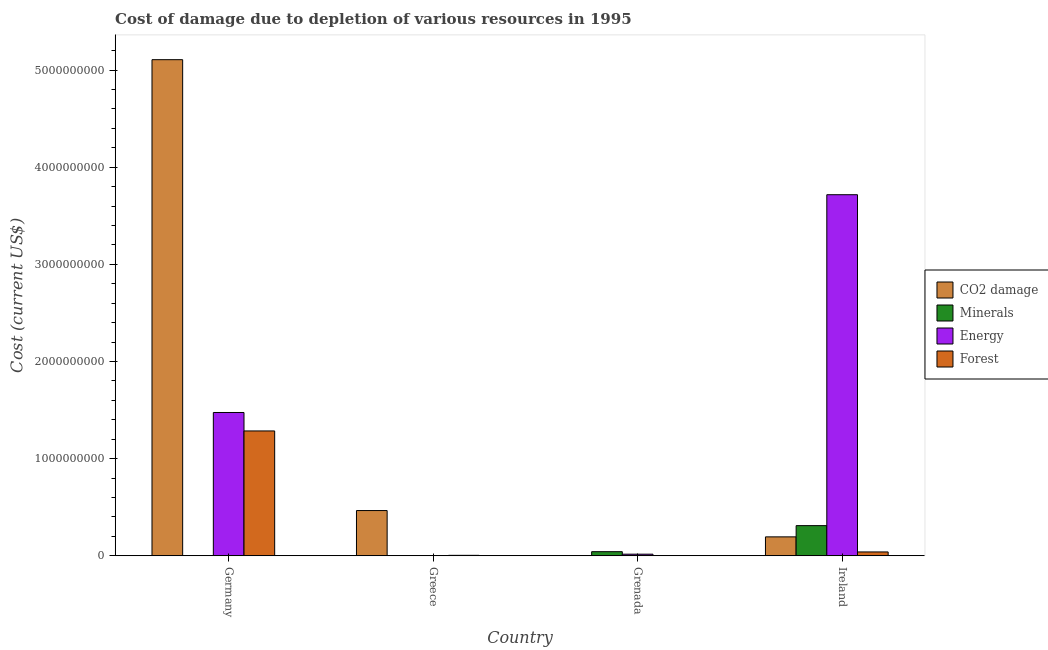Are the number of bars on each tick of the X-axis equal?
Make the answer very short. Yes. How many bars are there on the 3rd tick from the right?
Give a very brief answer. 4. What is the label of the 4th group of bars from the left?
Your response must be concise. Ireland. In how many cases, is the number of bars for a given country not equal to the number of legend labels?
Offer a very short reply. 0. What is the cost of damage due to depletion of minerals in Grenada?
Make the answer very short. 4.23e+07. Across all countries, what is the maximum cost of damage due to depletion of minerals?
Give a very brief answer. 3.10e+08. Across all countries, what is the minimum cost of damage due to depletion of coal?
Make the answer very short. 9.10e+05. In which country was the cost of damage due to depletion of minerals maximum?
Your answer should be very brief. Ireland. What is the total cost of damage due to depletion of energy in the graph?
Offer a terse response. 5.21e+09. What is the difference between the cost of damage due to depletion of minerals in Germany and that in Grenada?
Keep it short and to the point. -4.22e+07. What is the difference between the cost of damage due to depletion of coal in Grenada and the cost of damage due to depletion of forests in Ireland?
Provide a succinct answer. -3.88e+07. What is the average cost of damage due to depletion of coal per country?
Your answer should be very brief. 1.44e+09. What is the difference between the cost of damage due to depletion of forests and cost of damage due to depletion of minerals in Ireland?
Keep it short and to the point. -2.71e+08. What is the ratio of the cost of damage due to depletion of forests in Greece to that in Grenada?
Offer a terse response. 4.46. What is the difference between the highest and the second highest cost of damage due to depletion of energy?
Your answer should be compact. 2.24e+09. What is the difference between the highest and the lowest cost of damage due to depletion of minerals?
Your answer should be compact. 3.10e+08. In how many countries, is the cost of damage due to depletion of energy greater than the average cost of damage due to depletion of energy taken over all countries?
Provide a succinct answer. 2. What does the 1st bar from the left in Germany represents?
Your response must be concise. CO2 damage. What does the 1st bar from the right in Ireland represents?
Your response must be concise. Forest. Is it the case that in every country, the sum of the cost of damage due to depletion of coal and cost of damage due to depletion of minerals is greater than the cost of damage due to depletion of energy?
Your response must be concise. No. How many countries are there in the graph?
Offer a very short reply. 4. What is the difference between two consecutive major ticks on the Y-axis?
Your response must be concise. 1.00e+09. Are the values on the major ticks of Y-axis written in scientific E-notation?
Your response must be concise. No. Does the graph contain any zero values?
Provide a succinct answer. No. How many legend labels are there?
Your answer should be compact. 4. How are the legend labels stacked?
Give a very brief answer. Vertical. What is the title of the graph?
Offer a very short reply. Cost of damage due to depletion of various resources in 1995 . What is the label or title of the Y-axis?
Your answer should be very brief. Cost (current US$). What is the Cost (current US$) in CO2 damage in Germany?
Offer a terse response. 5.11e+09. What is the Cost (current US$) of Minerals in Germany?
Your response must be concise. 5.69e+04. What is the Cost (current US$) of Energy in Germany?
Give a very brief answer. 1.47e+09. What is the Cost (current US$) of Forest in Germany?
Provide a short and direct response. 1.29e+09. What is the Cost (current US$) of CO2 damage in Greece?
Your answer should be compact. 4.66e+08. What is the Cost (current US$) in Minerals in Greece?
Make the answer very short. 2.68e+06. What is the Cost (current US$) in Energy in Greece?
Provide a succinct answer. 2.56e+06. What is the Cost (current US$) in Forest in Greece?
Your answer should be very brief. 4.73e+06. What is the Cost (current US$) of CO2 damage in Grenada?
Your answer should be compact. 9.10e+05. What is the Cost (current US$) in Minerals in Grenada?
Offer a terse response. 4.23e+07. What is the Cost (current US$) of Energy in Grenada?
Provide a short and direct response. 1.66e+07. What is the Cost (current US$) of Forest in Grenada?
Offer a very short reply. 1.06e+06. What is the Cost (current US$) in CO2 damage in Ireland?
Your answer should be very brief. 1.95e+08. What is the Cost (current US$) in Minerals in Ireland?
Provide a succinct answer. 3.10e+08. What is the Cost (current US$) in Energy in Ireland?
Your response must be concise. 3.72e+09. What is the Cost (current US$) of Forest in Ireland?
Your answer should be compact. 3.97e+07. Across all countries, what is the maximum Cost (current US$) of CO2 damage?
Your response must be concise. 5.11e+09. Across all countries, what is the maximum Cost (current US$) in Minerals?
Make the answer very short. 3.10e+08. Across all countries, what is the maximum Cost (current US$) of Energy?
Provide a short and direct response. 3.72e+09. Across all countries, what is the maximum Cost (current US$) of Forest?
Your answer should be very brief. 1.29e+09. Across all countries, what is the minimum Cost (current US$) in CO2 damage?
Keep it short and to the point. 9.10e+05. Across all countries, what is the minimum Cost (current US$) of Minerals?
Offer a very short reply. 5.69e+04. Across all countries, what is the minimum Cost (current US$) in Energy?
Offer a very short reply. 2.56e+06. Across all countries, what is the minimum Cost (current US$) in Forest?
Offer a terse response. 1.06e+06. What is the total Cost (current US$) of CO2 damage in the graph?
Provide a succinct answer. 5.77e+09. What is the total Cost (current US$) of Minerals in the graph?
Your answer should be compact. 3.56e+08. What is the total Cost (current US$) in Energy in the graph?
Offer a terse response. 5.21e+09. What is the total Cost (current US$) of Forest in the graph?
Your answer should be compact. 1.33e+09. What is the difference between the Cost (current US$) of CO2 damage in Germany and that in Greece?
Give a very brief answer. 4.64e+09. What is the difference between the Cost (current US$) of Minerals in Germany and that in Greece?
Provide a succinct answer. -2.63e+06. What is the difference between the Cost (current US$) of Energy in Germany and that in Greece?
Your answer should be compact. 1.47e+09. What is the difference between the Cost (current US$) of Forest in Germany and that in Greece?
Your answer should be very brief. 1.28e+09. What is the difference between the Cost (current US$) of CO2 damage in Germany and that in Grenada?
Offer a terse response. 5.11e+09. What is the difference between the Cost (current US$) in Minerals in Germany and that in Grenada?
Provide a succinct answer. -4.22e+07. What is the difference between the Cost (current US$) of Energy in Germany and that in Grenada?
Make the answer very short. 1.46e+09. What is the difference between the Cost (current US$) in Forest in Germany and that in Grenada?
Offer a terse response. 1.28e+09. What is the difference between the Cost (current US$) of CO2 damage in Germany and that in Ireland?
Make the answer very short. 4.91e+09. What is the difference between the Cost (current US$) in Minerals in Germany and that in Ireland?
Offer a terse response. -3.10e+08. What is the difference between the Cost (current US$) of Energy in Germany and that in Ireland?
Your answer should be very brief. -2.24e+09. What is the difference between the Cost (current US$) of Forest in Germany and that in Ireland?
Ensure brevity in your answer.  1.25e+09. What is the difference between the Cost (current US$) in CO2 damage in Greece and that in Grenada?
Offer a very short reply. 4.65e+08. What is the difference between the Cost (current US$) of Minerals in Greece and that in Grenada?
Ensure brevity in your answer.  -3.96e+07. What is the difference between the Cost (current US$) in Energy in Greece and that in Grenada?
Keep it short and to the point. -1.40e+07. What is the difference between the Cost (current US$) of Forest in Greece and that in Grenada?
Offer a very short reply. 3.67e+06. What is the difference between the Cost (current US$) in CO2 damage in Greece and that in Ireland?
Make the answer very short. 2.71e+08. What is the difference between the Cost (current US$) in Minerals in Greece and that in Ireland?
Ensure brevity in your answer.  -3.08e+08. What is the difference between the Cost (current US$) in Energy in Greece and that in Ireland?
Provide a succinct answer. -3.71e+09. What is the difference between the Cost (current US$) of Forest in Greece and that in Ireland?
Provide a short and direct response. -3.49e+07. What is the difference between the Cost (current US$) of CO2 damage in Grenada and that in Ireland?
Provide a short and direct response. -1.94e+08. What is the difference between the Cost (current US$) in Minerals in Grenada and that in Ireland?
Provide a succinct answer. -2.68e+08. What is the difference between the Cost (current US$) of Energy in Grenada and that in Ireland?
Your answer should be very brief. -3.70e+09. What is the difference between the Cost (current US$) of Forest in Grenada and that in Ireland?
Your response must be concise. -3.86e+07. What is the difference between the Cost (current US$) in CO2 damage in Germany and the Cost (current US$) in Minerals in Greece?
Offer a terse response. 5.10e+09. What is the difference between the Cost (current US$) in CO2 damage in Germany and the Cost (current US$) in Energy in Greece?
Provide a succinct answer. 5.10e+09. What is the difference between the Cost (current US$) of CO2 damage in Germany and the Cost (current US$) of Forest in Greece?
Make the answer very short. 5.10e+09. What is the difference between the Cost (current US$) of Minerals in Germany and the Cost (current US$) of Energy in Greece?
Keep it short and to the point. -2.51e+06. What is the difference between the Cost (current US$) in Minerals in Germany and the Cost (current US$) in Forest in Greece?
Ensure brevity in your answer.  -4.67e+06. What is the difference between the Cost (current US$) in Energy in Germany and the Cost (current US$) in Forest in Greece?
Offer a very short reply. 1.47e+09. What is the difference between the Cost (current US$) of CO2 damage in Germany and the Cost (current US$) of Minerals in Grenada?
Make the answer very short. 5.06e+09. What is the difference between the Cost (current US$) in CO2 damage in Germany and the Cost (current US$) in Energy in Grenada?
Offer a very short reply. 5.09e+09. What is the difference between the Cost (current US$) in CO2 damage in Germany and the Cost (current US$) in Forest in Grenada?
Offer a very short reply. 5.11e+09. What is the difference between the Cost (current US$) of Minerals in Germany and the Cost (current US$) of Energy in Grenada?
Keep it short and to the point. -1.65e+07. What is the difference between the Cost (current US$) of Minerals in Germany and the Cost (current US$) of Forest in Grenada?
Make the answer very short. -1.00e+06. What is the difference between the Cost (current US$) in Energy in Germany and the Cost (current US$) in Forest in Grenada?
Provide a short and direct response. 1.47e+09. What is the difference between the Cost (current US$) in CO2 damage in Germany and the Cost (current US$) in Minerals in Ireland?
Give a very brief answer. 4.80e+09. What is the difference between the Cost (current US$) of CO2 damage in Germany and the Cost (current US$) of Energy in Ireland?
Provide a succinct answer. 1.39e+09. What is the difference between the Cost (current US$) of CO2 damage in Germany and the Cost (current US$) of Forest in Ireland?
Ensure brevity in your answer.  5.07e+09. What is the difference between the Cost (current US$) of Minerals in Germany and the Cost (current US$) of Energy in Ireland?
Offer a terse response. -3.72e+09. What is the difference between the Cost (current US$) of Minerals in Germany and the Cost (current US$) of Forest in Ireland?
Keep it short and to the point. -3.96e+07. What is the difference between the Cost (current US$) of Energy in Germany and the Cost (current US$) of Forest in Ireland?
Offer a very short reply. 1.44e+09. What is the difference between the Cost (current US$) in CO2 damage in Greece and the Cost (current US$) in Minerals in Grenada?
Give a very brief answer. 4.23e+08. What is the difference between the Cost (current US$) in CO2 damage in Greece and the Cost (current US$) in Energy in Grenada?
Your response must be concise. 4.49e+08. What is the difference between the Cost (current US$) in CO2 damage in Greece and the Cost (current US$) in Forest in Grenada?
Your answer should be very brief. 4.64e+08. What is the difference between the Cost (current US$) of Minerals in Greece and the Cost (current US$) of Energy in Grenada?
Give a very brief answer. -1.39e+07. What is the difference between the Cost (current US$) of Minerals in Greece and the Cost (current US$) of Forest in Grenada?
Ensure brevity in your answer.  1.62e+06. What is the difference between the Cost (current US$) in Energy in Greece and the Cost (current US$) in Forest in Grenada?
Provide a succinct answer. 1.51e+06. What is the difference between the Cost (current US$) in CO2 damage in Greece and the Cost (current US$) in Minerals in Ireland?
Your response must be concise. 1.55e+08. What is the difference between the Cost (current US$) in CO2 damage in Greece and the Cost (current US$) in Energy in Ireland?
Keep it short and to the point. -3.25e+09. What is the difference between the Cost (current US$) in CO2 damage in Greece and the Cost (current US$) in Forest in Ireland?
Ensure brevity in your answer.  4.26e+08. What is the difference between the Cost (current US$) of Minerals in Greece and the Cost (current US$) of Energy in Ireland?
Make the answer very short. -3.71e+09. What is the difference between the Cost (current US$) in Minerals in Greece and the Cost (current US$) in Forest in Ireland?
Keep it short and to the point. -3.70e+07. What is the difference between the Cost (current US$) of Energy in Greece and the Cost (current US$) of Forest in Ireland?
Provide a short and direct response. -3.71e+07. What is the difference between the Cost (current US$) of CO2 damage in Grenada and the Cost (current US$) of Minerals in Ireland?
Your response must be concise. -3.10e+08. What is the difference between the Cost (current US$) in CO2 damage in Grenada and the Cost (current US$) in Energy in Ireland?
Your answer should be very brief. -3.72e+09. What is the difference between the Cost (current US$) in CO2 damage in Grenada and the Cost (current US$) in Forest in Ireland?
Provide a short and direct response. -3.88e+07. What is the difference between the Cost (current US$) in Minerals in Grenada and the Cost (current US$) in Energy in Ireland?
Offer a terse response. -3.67e+09. What is the difference between the Cost (current US$) of Minerals in Grenada and the Cost (current US$) of Forest in Ireland?
Your answer should be very brief. 2.64e+06. What is the difference between the Cost (current US$) of Energy in Grenada and the Cost (current US$) of Forest in Ireland?
Provide a succinct answer. -2.31e+07. What is the average Cost (current US$) of CO2 damage per country?
Your response must be concise. 1.44e+09. What is the average Cost (current US$) of Minerals per country?
Provide a short and direct response. 8.89e+07. What is the average Cost (current US$) of Energy per country?
Give a very brief answer. 1.30e+09. What is the average Cost (current US$) of Forest per country?
Offer a very short reply. 3.33e+08. What is the difference between the Cost (current US$) of CO2 damage and Cost (current US$) of Minerals in Germany?
Provide a succinct answer. 5.11e+09. What is the difference between the Cost (current US$) of CO2 damage and Cost (current US$) of Energy in Germany?
Make the answer very short. 3.63e+09. What is the difference between the Cost (current US$) of CO2 damage and Cost (current US$) of Forest in Germany?
Ensure brevity in your answer.  3.82e+09. What is the difference between the Cost (current US$) in Minerals and Cost (current US$) in Energy in Germany?
Provide a succinct answer. -1.47e+09. What is the difference between the Cost (current US$) of Minerals and Cost (current US$) of Forest in Germany?
Your answer should be compact. -1.29e+09. What is the difference between the Cost (current US$) in Energy and Cost (current US$) in Forest in Germany?
Provide a succinct answer. 1.90e+08. What is the difference between the Cost (current US$) in CO2 damage and Cost (current US$) in Minerals in Greece?
Keep it short and to the point. 4.63e+08. What is the difference between the Cost (current US$) in CO2 damage and Cost (current US$) in Energy in Greece?
Give a very brief answer. 4.63e+08. What is the difference between the Cost (current US$) of CO2 damage and Cost (current US$) of Forest in Greece?
Offer a terse response. 4.61e+08. What is the difference between the Cost (current US$) of Minerals and Cost (current US$) of Energy in Greece?
Make the answer very short. 1.20e+05. What is the difference between the Cost (current US$) of Minerals and Cost (current US$) of Forest in Greece?
Ensure brevity in your answer.  -2.04e+06. What is the difference between the Cost (current US$) in Energy and Cost (current US$) in Forest in Greece?
Give a very brief answer. -2.16e+06. What is the difference between the Cost (current US$) in CO2 damage and Cost (current US$) in Minerals in Grenada?
Your answer should be compact. -4.14e+07. What is the difference between the Cost (current US$) in CO2 damage and Cost (current US$) in Energy in Grenada?
Your answer should be compact. -1.56e+07. What is the difference between the Cost (current US$) in CO2 damage and Cost (current US$) in Forest in Grenada?
Offer a very short reply. -1.50e+05. What is the difference between the Cost (current US$) of Minerals and Cost (current US$) of Energy in Grenada?
Ensure brevity in your answer.  2.58e+07. What is the difference between the Cost (current US$) of Minerals and Cost (current US$) of Forest in Grenada?
Provide a succinct answer. 4.12e+07. What is the difference between the Cost (current US$) in Energy and Cost (current US$) in Forest in Grenada?
Give a very brief answer. 1.55e+07. What is the difference between the Cost (current US$) of CO2 damage and Cost (current US$) of Minerals in Ireland?
Make the answer very short. -1.16e+08. What is the difference between the Cost (current US$) of CO2 damage and Cost (current US$) of Energy in Ireland?
Your response must be concise. -3.52e+09. What is the difference between the Cost (current US$) in CO2 damage and Cost (current US$) in Forest in Ireland?
Your answer should be very brief. 1.55e+08. What is the difference between the Cost (current US$) of Minerals and Cost (current US$) of Energy in Ireland?
Your answer should be very brief. -3.41e+09. What is the difference between the Cost (current US$) of Minerals and Cost (current US$) of Forest in Ireland?
Your answer should be very brief. 2.71e+08. What is the difference between the Cost (current US$) of Energy and Cost (current US$) of Forest in Ireland?
Offer a terse response. 3.68e+09. What is the ratio of the Cost (current US$) in CO2 damage in Germany to that in Greece?
Give a very brief answer. 10.97. What is the ratio of the Cost (current US$) in Minerals in Germany to that in Greece?
Your answer should be very brief. 0.02. What is the ratio of the Cost (current US$) of Energy in Germany to that in Greece?
Keep it short and to the point. 575.07. What is the ratio of the Cost (current US$) of Forest in Germany to that in Greece?
Provide a short and direct response. 271.75. What is the ratio of the Cost (current US$) in CO2 damage in Germany to that in Grenada?
Provide a succinct answer. 5610.6. What is the ratio of the Cost (current US$) in Minerals in Germany to that in Grenada?
Keep it short and to the point. 0. What is the ratio of the Cost (current US$) in Energy in Germany to that in Grenada?
Offer a terse response. 89.12. What is the ratio of the Cost (current US$) of Forest in Germany to that in Grenada?
Offer a very short reply. 1212.73. What is the ratio of the Cost (current US$) of CO2 damage in Germany to that in Ireland?
Your answer should be compact. 26.22. What is the ratio of the Cost (current US$) in Energy in Germany to that in Ireland?
Provide a short and direct response. 0.4. What is the ratio of the Cost (current US$) of Forest in Germany to that in Ireland?
Your answer should be compact. 32.4. What is the ratio of the Cost (current US$) in CO2 damage in Greece to that in Grenada?
Give a very brief answer. 511.52. What is the ratio of the Cost (current US$) in Minerals in Greece to that in Grenada?
Offer a terse response. 0.06. What is the ratio of the Cost (current US$) in Energy in Greece to that in Grenada?
Keep it short and to the point. 0.15. What is the ratio of the Cost (current US$) of Forest in Greece to that in Grenada?
Ensure brevity in your answer.  4.46. What is the ratio of the Cost (current US$) in CO2 damage in Greece to that in Ireland?
Make the answer very short. 2.39. What is the ratio of the Cost (current US$) in Minerals in Greece to that in Ireland?
Provide a short and direct response. 0.01. What is the ratio of the Cost (current US$) in Energy in Greece to that in Ireland?
Offer a terse response. 0. What is the ratio of the Cost (current US$) in Forest in Greece to that in Ireland?
Offer a very short reply. 0.12. What is the ratio of the Cost (current US$) in CO2 damage in Grenada to that in Ireland?
Offer a very short reply. 0. What is the ratio of the Cost (current US$) of Minerals in Grenada to that in Ireland?
Your answer should be very brief. 0.14. What is the ratio of the Cost (current US$) of Energy in Grenada to that in Ireland?
Provide a succinct answer. 0. What is the ratio of the Cost (current US$) of Forest in Grenada to that in Ireland?
Offer a very short reply. 0.03. What is the difference between the highest and the second highest Cost (current US$) in CO2 damage?
Provide a short and direct response. 4.64e+09. What is the difference between the highest and the second highest Cost (current US$) in Minerals?
Provide a short and direct response. 2.68e+08. What is the difference between the highest and the second highest Cost (current US$) of Energy?
Ensure brevity in your answer.  2.24e+09. What is the difference between the highest and the second highest Cost (current US$) in Forest?
Provide a succinct answer. 1.25e+09. What is the difference between the highest and the lowest Cost (current US$) of CO2 damage?
Provide a short and direct response. 5.11e+09. What is the difference between the highest and the lowest Cost (current US$) of Minerals?
Make the answer very short. 3.10e+08. What is the difference between the highest and the lowest Cost (current US$) in Energy?
Your answer should be compact. 3.71e+09. What is the difference between the highest and the lowest Cost (current US$) of Forest?
Your response must be concise. 1.28e+09. 